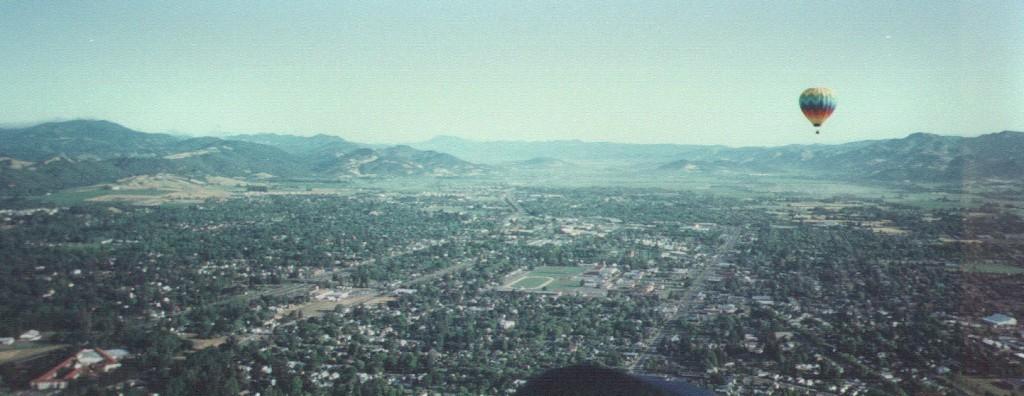Please provide a concise description of this image. In the background of the image there are mountains. There is a air balloon. At the bottom of the image there are trees, buildings. At the top of the image there is sky 